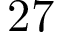<formula> <loc_0><loc_0><loc_500><loc_500>2 7</formula> 